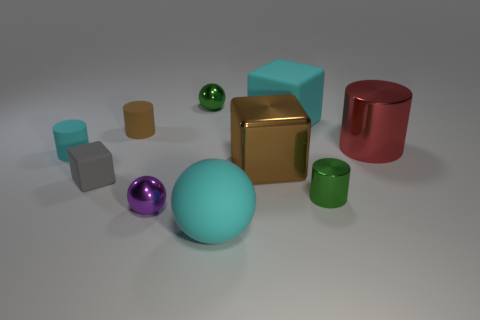Does the red thing have the same material as the green thing that is behind the gray block?
Provide a succinct answer. Yes. What is the shape of the cyan object in front of the tiny purple object?
Provide a succinct answer. Sphere. How many other objects are there of the same material as the red cylinder?
Provide a succinct answer. 4. The matte ball has what size?
Keep it short and to the point. Large. What number of other objects are the same color as the large metal cube?
Offer a very short reply. 1. What color is the metallic thing that is both on the left side of the cyan rubber sphere and behind the small purple object?
Your response must be concise. Green. How many shiny cylinders are there?
Provide a short and direct response. 2. Do the tiny cyan thing and the cyan block have the same material?
Your response must be concise. Yes. What shape is the big brown object that is left of the metal cylinder that is behind the tiny green shiny thing that is right of the large cyan rubber ball?
Keep it short and to the point. Cube. Are the large cyan thing that is in front of the big rubber cube and the tiny cyan cylinder behind the tiny rubber cube made of the same material?
Your response must be concise. Yes. 